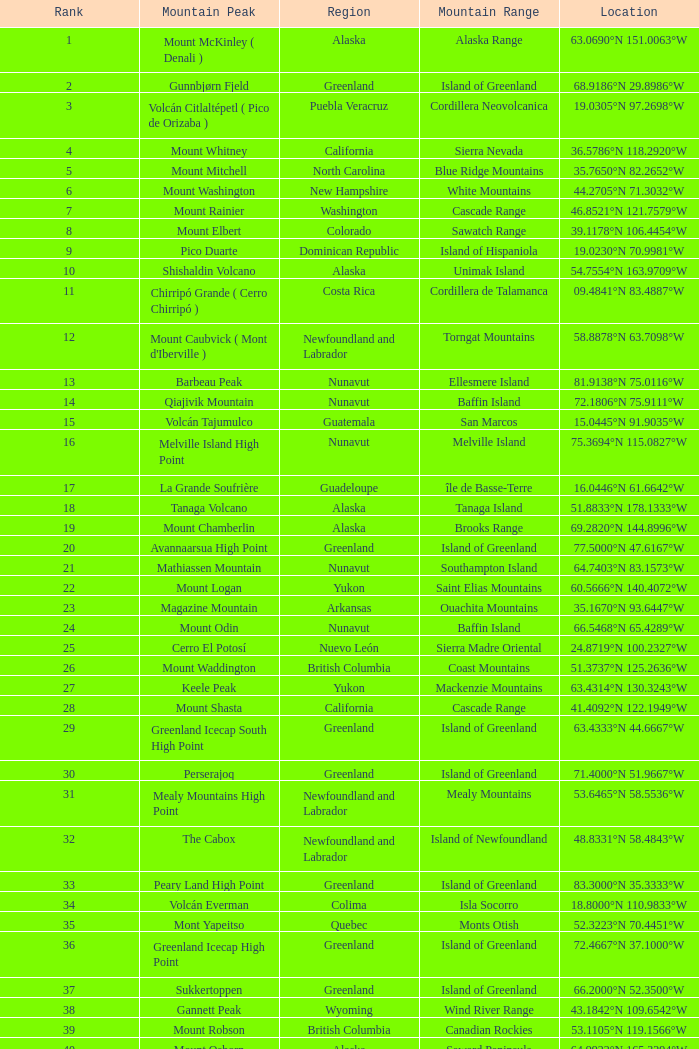Identify the mountain summit with a ranking of 62? Cerro Nube ( Quie Yelaag ). 